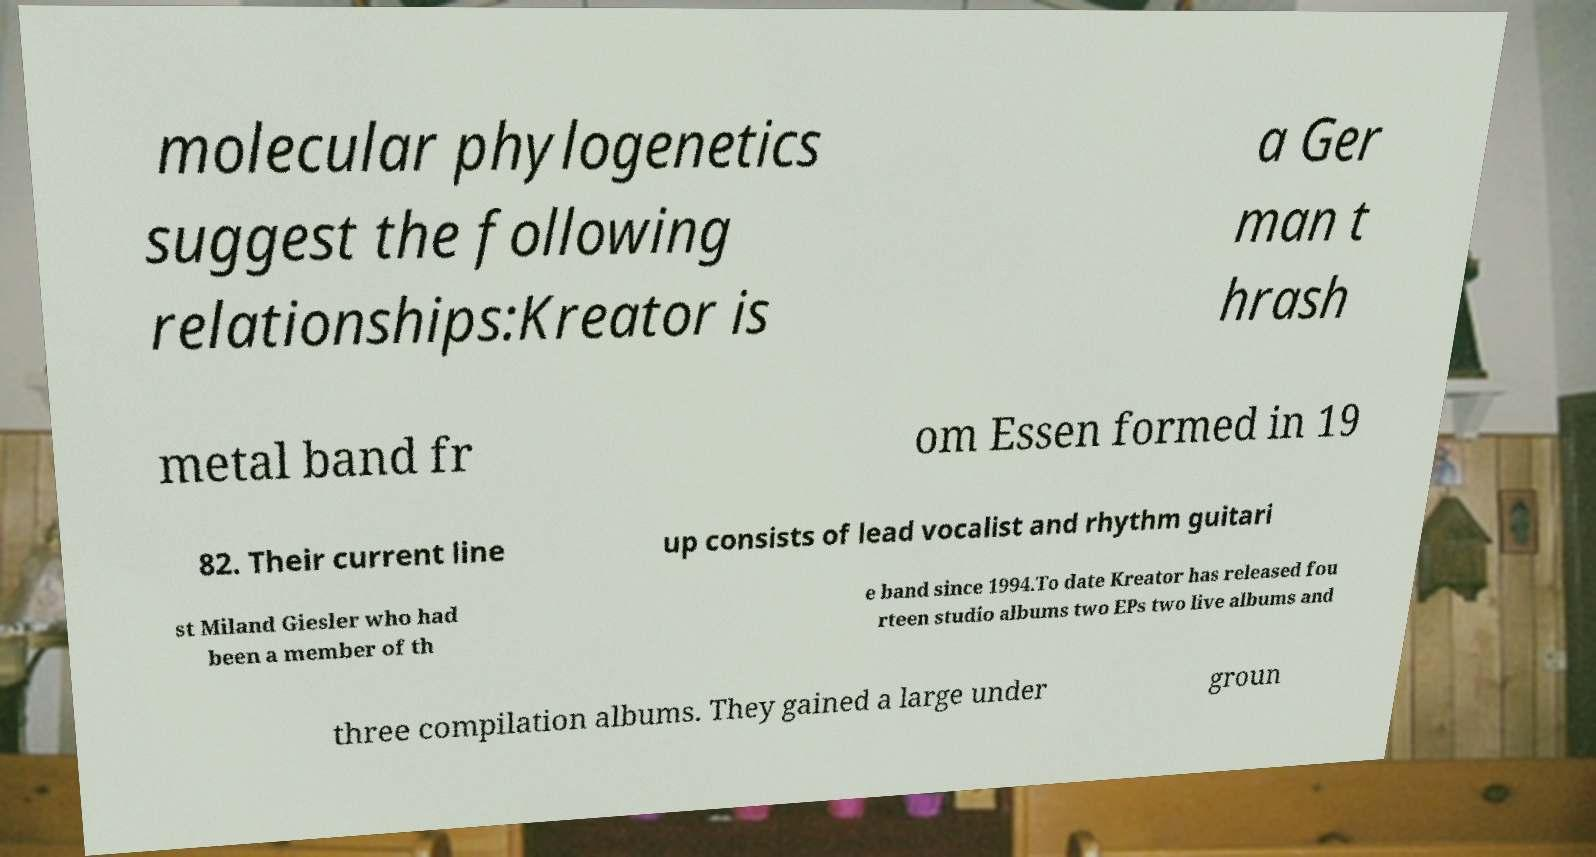I need the written content from this picture converted into text. Can you do that? molecular phylogenetics suggest the following relationships:Kreator is a Ger man t hrash metal band fr om Essen formed in 19 82. Their current line up consists of lead vocalist and rhythm guitari st Miland Giesler who had been a member of th e band since 1994.To date Kreator has released fou rteen studio albums two EPs two live albums and three compilation albums. They gained a large under groun 